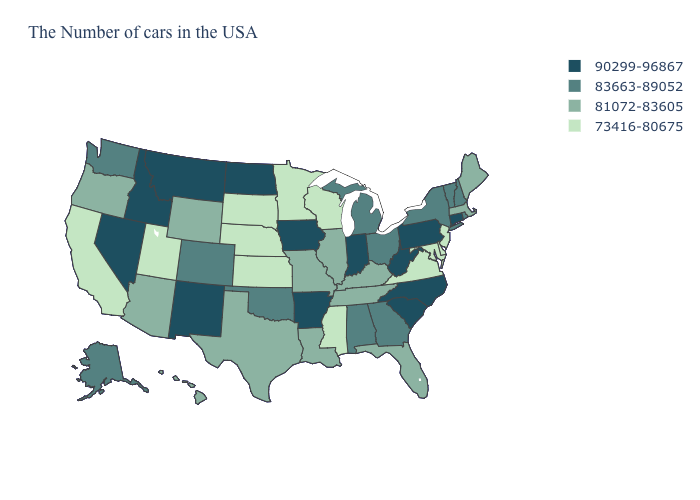Is the legend a continuous bar?
Short answer required. No. What is the lowest value in the South?
Short answer required. 73416-80675. What is the value of Delaware?
Short answer required. 73416-80675. Name the states that have a value in the range 90299-96867?
Answer briefly. Connecticut, Pennsylvania, North Carolina, South Carolina, West Virginia, Indiana, Arkansas, Iowa, North Dakota, New Mexico, Montana, Idaho, Nevada. What is the value of Hawaii?
Give a very brief answer. 81072-83605. What is the lowest value in the Northeast?
Quick response, please. 73416-80675. Name the states that have a value in the range 81072-83605?
Be succinct. Maine, Massachusetts, Florida, Kentucky, Tennessee, Illinois, Louisiana, Missouri, Texas, Wyoming, Arizona, Oregon, Hawaii. Which states have the lowest value in the Northeast?
Quick response, please. New Jersey. What is the value of Illinois?
Quick response, please. 81072-83605. Does Georgia have the same value as Iowa?
Be succinct. No. Name the states that have a value in the range 83663-89052?
Be succinct. Rhode Island, New Hampshire, Vermont, New York, Ohio, Georgia, Michigan, Alabama, Oklahoma, Colorado, Washington, Alaska. Is the legend a continuous bar?
Be succinct. No. Which states have the lowest value in the West?
Short answer required. Utah, California. Name the states that have a value in the range 90299-96867?
Write a very short answer. Connecticut, Pennsylvania, North Carolina, South Carolina, West Virginia, Indiana, Arkansas, Iowa, North Dakota, New Mexico, Montana, Idaho, Nevada. Is the legend a continuous bar?
Concise answer only. No. 